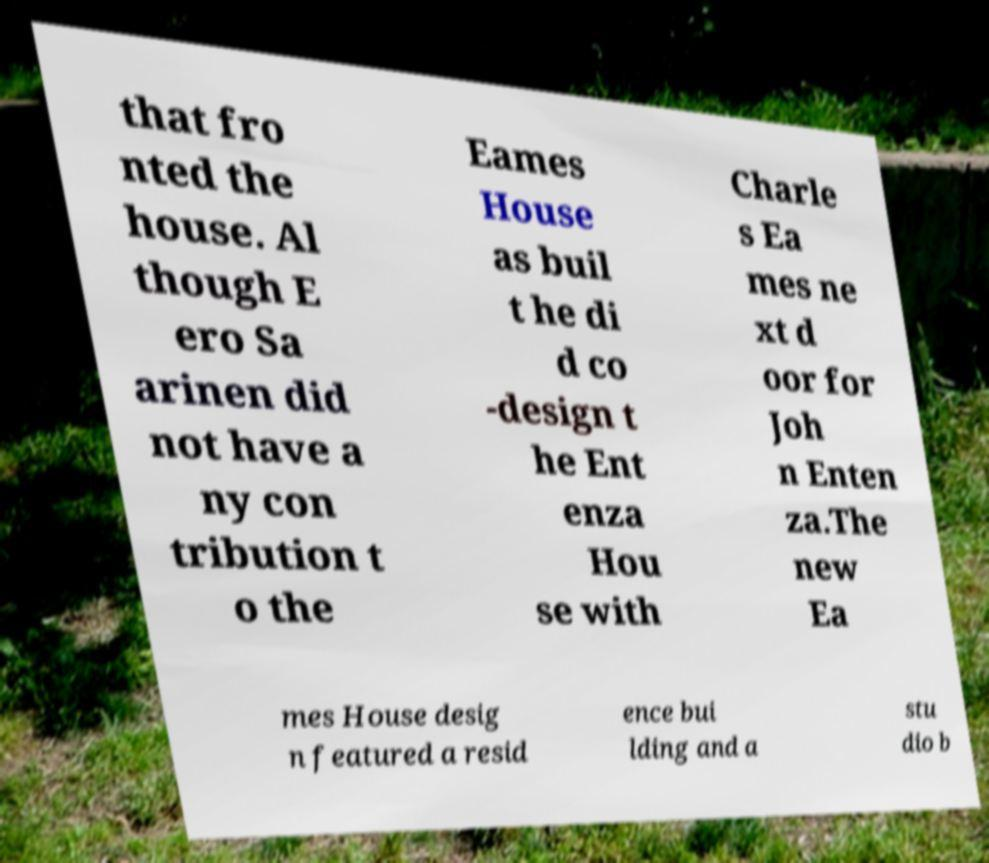What messages or text are displayed in this image? I need them in a readable, typed format. that fro nted the house. Al though E ero Sa arinen did not have a ny con tribution t o the Eames House as buil t he di d co -design t he Ent enza Hou se with Charle s Ea mes ne xt d oor for Joh n Enten za.The new Ea mes House desig n featured a resid ence bui lding and a stu dio b 